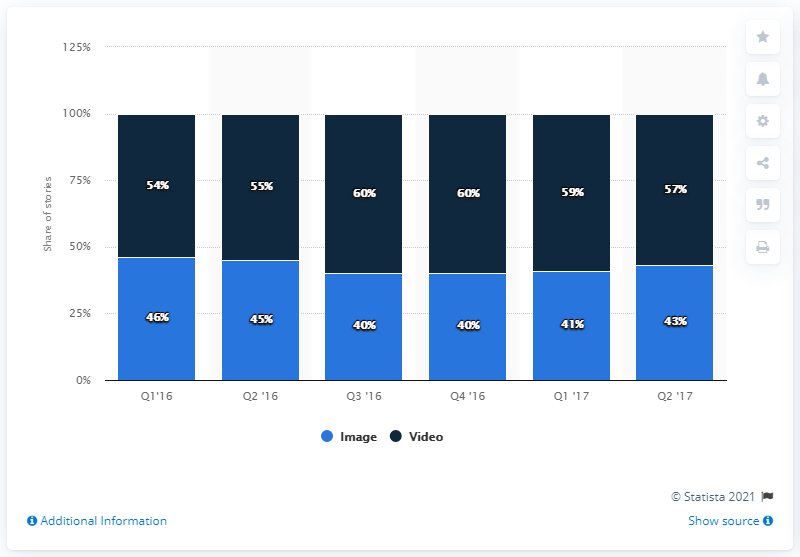Highlight a few significant elements in this photo. The modes of the graph are the values that appear most frequently in the dataset. In this case, the modes are 46 and 60. The average number of images in Snapchat stories is 42.5. 